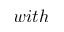<formula> <loc_0><loc_0><loc_500><loc_500>w i t h</formula> 